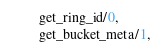<code> <loc_0><loc_0><loc_500><loc_500><_Erlang_>         get_ring_id/0,
         get_bucket_meta/1,</code> 